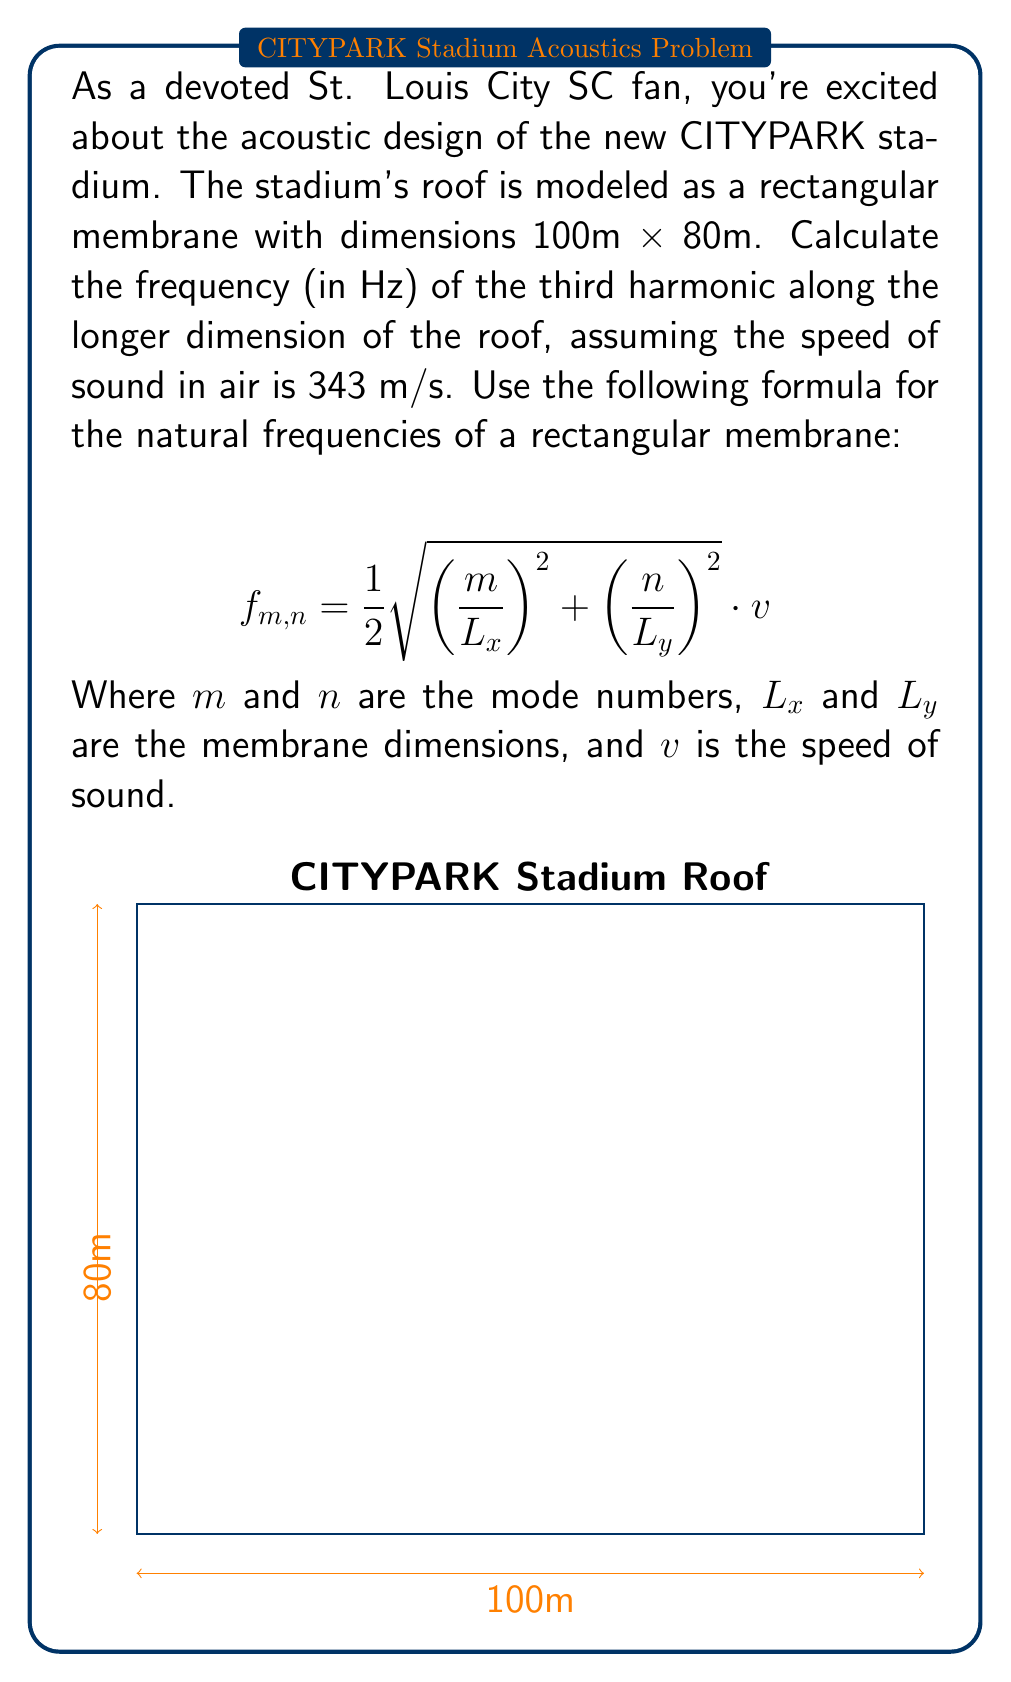Teach me how to tackle this problem. Let's approach this step-by-step:

1) We're looking for the third harmonic along the longer dimension, which is 100m. This means $m = 3$ and $n = 0$.

2) We're given:
   $L_x = 100$ m
   $L_y = 80$ m
   $v = 343$ m/s

3) Substituting these values into the formula:

   $$f_{3,0} = \frac{1}{2} \sqrt{\left(\frac{3}{100}\right)^2 + \left(\frac{0}{80}\right)^2} \cdot 343$$

4) Simplify inside the square root:

   $$f_{3,0} = \frac{1}{2} \sqrt{\frac{9}{10000} + 0} \cdot 343$$

5) Calculate:

   $$f_{3,0} = \frac{1}{2} \sqrt{\frac{9}{10000}} \cdot 343$$

   $$f_{3,0} = \frac{1}{2} \cdot \frac{3}{100} \cdot 343$$

   $$f_{3,0} = \frac{343 \cdot 3}{200} = 5.145$$

6) Round to two decimal places:

   $$f_{3,0} \approx 5.15 \text{ Hz}$$

This frequency represents the third harmonic along the longer dimension of the CITYPARK stadium roof.
Answer: 5.15 Hz 